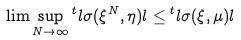<formula> <loc_0><loc_0><loc_500><loc_500>\lim \sup _ { N \rightarrow \infty } { ^ { t } l } \sigma ( \xi ^ { N } , \eta ) l \leq { ^ { t } l } \sigma ( \xi , \mu ) l</formula> 